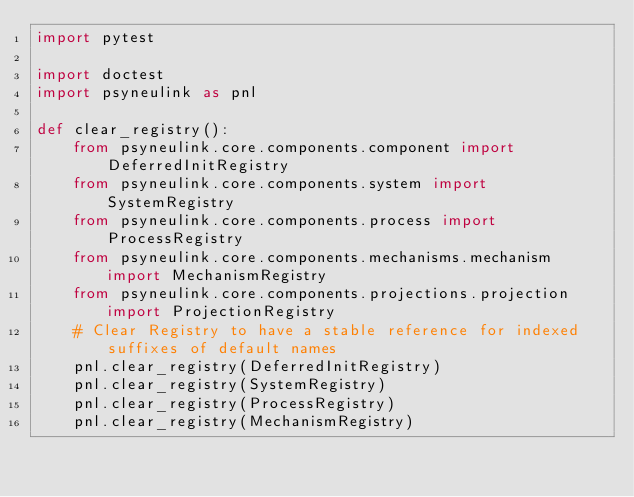Convert code to text. <code><loc_0><loc_0><loc_500><loc_500><_Python_>import pytest

import doctest
import psyneulink as pnl

def clear_registry():
    from psyneulink.core.components.component import DeferredInitRegistry
    from psyneulink.core.components.system import SystemRegistry
    from psyneulink.core.components.process import ProcessRegistry
    from psyneulink.core.components.mechanisms.mechanism import MechanismRegistry
    from psyneulink.core.components.projections.projection import ProjectionRegistry
    # Clear Registry to have a stable reference for indexed suffixes of default names
    pnl.clear_registry(DeferredInitRegistry)
    pnl.clear_registry(SystemRegistry)
    pnl.clear_registry(ProcessRegistry)
    pnl.clear_registry(MechanismRegistry)</code> 